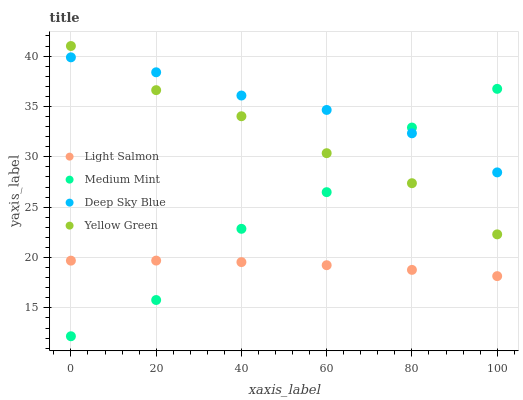Does Light Salmon have the minimum area under the curve?
Answer yes or no. Yes. Does Deep Sky Blue have the maximum area under the curve?
Answer yes or no. Yes. Does Yellow Green have the minimum area under the curve?
Answer yes or no. No. Does Yellow Green have the maximum area under the curve?
Answer yes or no. No. Is Light Salmon the smoothest?
Answer yes or no. Yes. Is Medium Mint the roughest?
Answer yes or no. Yes. Is Yellow Green the smoothest?
Answer yes or no. No. Is Yellow Green the roughest?
Answer yes or no. No. Does Medium Mint have the lowest value?
Answer yes or no. Yes. Does Light Salmon have the lowest value?
Answer yes or no. No. Does Yellow Green have the highest value?
Answer yes or no. Yes. Does Light Salmon have the highest value?
Answer yes or no. No. Is Light Salmon less than Yellow Green?
Answer yes or no. Yes. Is Deep Sky Blue greater than Light Salmon?
Answer yes or no. Yes. Does Yellow Green intersect Medium Mint?
Answer yes or no. Yes. Is Yellow Green less than Medium Mint?
Answer yes or no. No. Is Yellow Green greater than Medium Mint?
Answer yes or no. No. Does Light Salmon intersect Yellow Green?
Answer yes or no. No. 